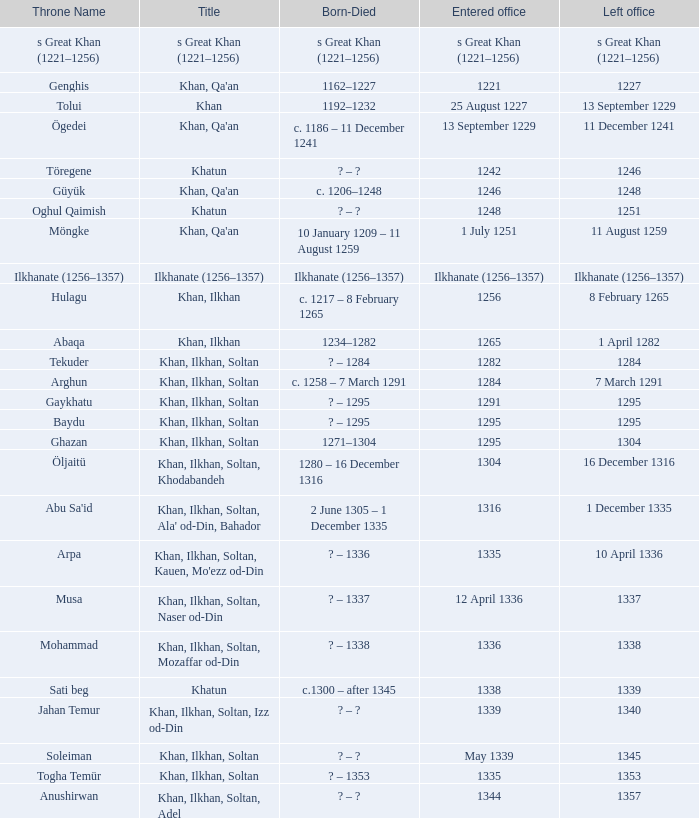What are the dates of birth and death for the person who entered office on 13 september 1229? C. 1186 – 11 december 1241. 